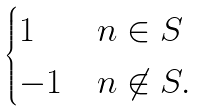Convert formula to latex. <formula><loc_0><loc_0><loc_500><loc_500>\begin{cases} 1 & n \in S \\ - 1 & n \not \in S . \end{cases}</formula> 